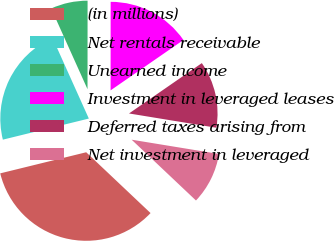Convert chart. <chart><loc_0><loc_0><loc_500><loc_500><pie_chart><fcel>(in millions)<fcel>Net rentals receivable<fcel>Unearned income<fcel>Investment in leveraged leases<fcel>Deferred taxes arising from<fcel>Net investment in leveraged<nl><fcel>34.12%<fcel>22.1%<fcel>6.74%<fcel>15.36%<fcel>12.21%<fcel>9.47%<nl></chart> 